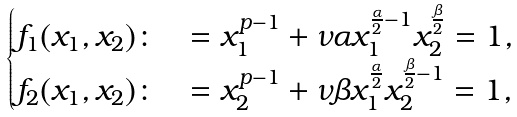Convert formula to latex. <formula><loc_0><loc_0><loc_500><loc_500>\begin{cases} f _ { 1 } ( x _ { 1 } , x _ { 2 } ) \colon & = x _ { 1 } ^ { p - 1 } + \nu \alpha x _ { 1 } ^ { \frac { \alpha } { 2 } - 1 } x _ { 2 } ^ { \frac { \beta } { 2 } } = 1 , \\ f _ { 2 } ( x _ { 1 } , x _ { 2 } ) \colon & = x _ { 2 } ^ { p - 1 } + \nu \beta x _ { 1 } ^ { \frac { \alpha } { 2 } } x _ { 2 } ^ { \frac { \beta } { 2 } - 1 } = 1 , \end{cases}</formula> 